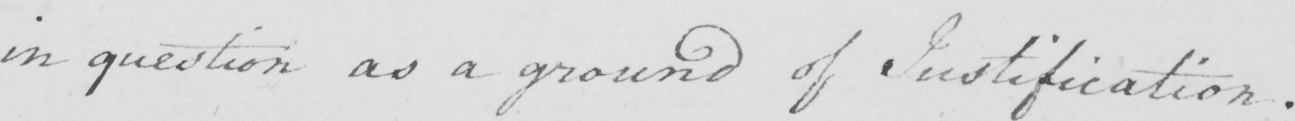Please provide the text content of this handwritten line. in question as a ground of Justification . 